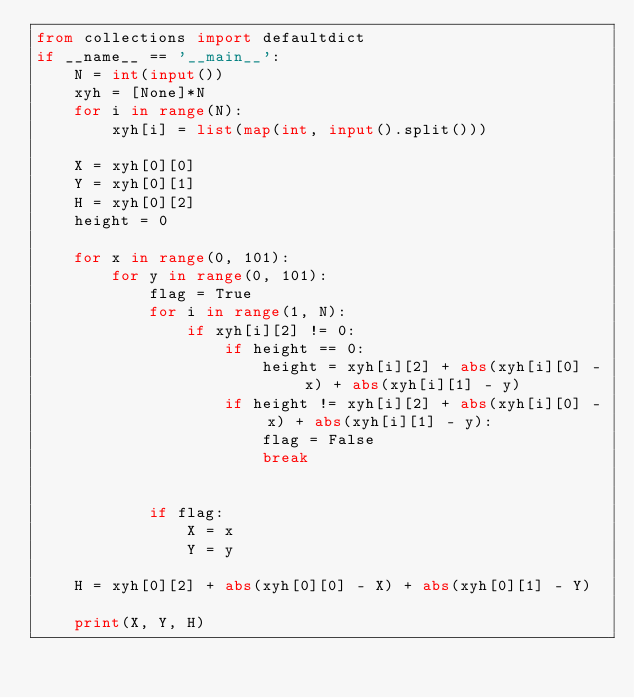Convert code to text. <code><loc_0><loc_0><loc_500><loc_500><_Python_>from collections import defaultdict
if __name__ == '__main__':
    N = int(input())
    xyh = [None]*N
    for i in range(N):
        xyh[i] = list(map(int, input().split()))
    
    X = xyh[0][0]
    Y = xyh[0][1]
    H = xyh[0][2]
    height = 0
    
    for x in range(0, 101):
        for y in range(0, 101):
            flag = True
            for i in range(1, N):
                if xyh[i][2] != 0:
                    if height == 0:
                        height = xyh[i][2] + abs(xyh[i][0] - x) + abs(xyh[i][1] - y)
                    if height != xyh[i][2] + abs(xyh[i][0] - x) + abs(xyh[i][1] - y):
                        flag = False
                        break
                    
            
            if flag:
                X = x
                Y = y
                    
    H = xyh[0][2] + abs(xyh[0][0] - X) + abs(xyh[0][1] - Y)
    
    print(X, Y, H)</code> 